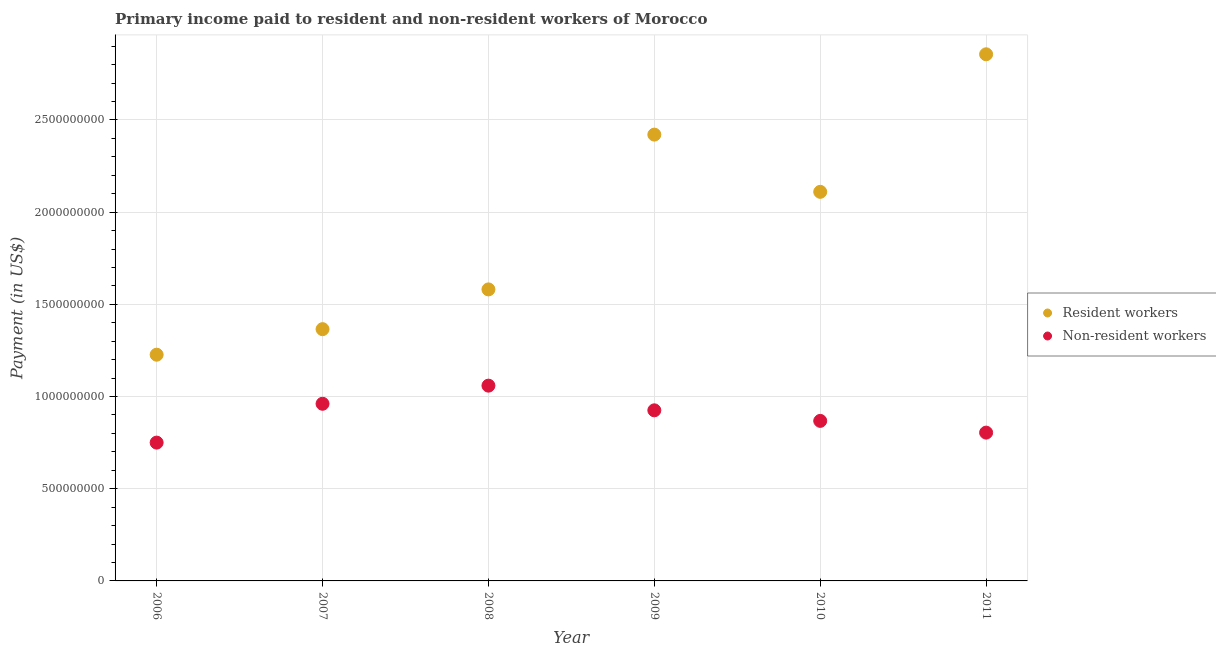What is the payment made to resident workers in 2010?
Your response must be concise. 2.11e+09. Across all years, what is the maximum payment made to resident workers?
Offer a very short reply. 2.86e+09. Across all years, what is the minimum payment made to resident workers?
Provide a succinct answer. 1.23e+09. In which year was the payment made to non-resident workers maximum?
Your response must be concise. 2008. What is the total payment made to resident workers in the graph?
Provide a succinct answer. 1.16e+1. What is the difference between the payment made to resident workers in 2007 and that in 2008?
Provide a succinct answer. -2.16e+08. What is the difference between the payment made to non-resident workers in 2010 and the payment made to resident workers in 2006?
Your response must be concise. -3.59e+08. What is the average payment made to resident workers per year?
Make the answer very short. 1.93e+09. In the year 2011, what is the difference between the payment made to non-resident workers and payment made to resident workers?
Provide a succinct answer. -2.05e+09. What is the ratio of the payment made to non-resident workers in 2010 to that in 2011?
Make the answer very short. 1.08. Is the payment made to non-resident workers in 2008 less than that in 2009?
Your answer should be very brief. No. Is the difference between the payment made to resident workers in 2007 and 2010 greater than the difference between the payment made to non-resident workers in 2007 and 2010?
Your answer should be compact. No. What is the difference between the highest and the second highest payment made to resident workers?
Your response must be concise. 4.36e+08. What is the difference between the highest and the lowest payment made to non-resident workers?
Make the answer very short. 3.09e+08. Is the sum of the payment made to resident workers in 2009 and 2011 greater than the maximum payment made to non-resident workers across all years?
Offer a terse response. Yes. Does the payment made to resident workers monotonically increase over the years?
Make the answer very short. No. Is the payment made to resident workers strictly greater than the payment made to non-resident workers over the years?
Ensure brevity in your answer.  Yes. How many years are there in the graph?
Provide a succinct answer. 6. What is the difference between two consecutive major ticks on the Y-axis?
Provide a succinct answer. 5.00e+08. Are the values on the major ticks of Y-axis written in scientific E-notation?
Your answer should be compact. No. Does the graph contain grids?
Your answer should be compact. Yes. Where does the legend appear in the graph?
Ensure brevity in your answer.  Center right. What is the title of the graph?
Your answer should be very brief. Primary income paid to resident and non-resident workers of Morocco. Does "Register a property" appear as one of the legend labels in the graph?
Your answer should be compact. No. What is the label or title of the Y-axis?
Make the answer very short. Payment (in US$). What is the Payment (in US$) in Resident workers in 2006?
Give a very brief answer. 1.23e+09. What is the Payment (in US$) of Non-resident workers in 2006?
Your response must be concise. 7.50e+08. What is the Payment (in US$) of Resident workers in 2007?
Make the answer very short. 1.37e+09. What is the Payment (in US$) in Non-resident workers in 2007?
Provide a short and direct response. 9.61e+08. What is the Payment (in US$) in Resident workers in 2008?
Offer a terse response. 1.58e+09. What is the Payment (in US$) in Non-resident workers in 2008?
Offer a very short reply. 1.06e+09. What is the Payment (in US$) in Resident workers in 2009?
Make the answer very short. 2.42e+09. What is the Payment (in US$) of Non-resident workers in 2009?
Make the answer very short. 9.25e+08. What is the Payment (in US$) in Resident workers in 2010?
Offer a terse response. 2.11e+09. What is the Payment (in US$) of Non-resident workers in 2010?
Give a very brief answer. 8.68e+08. What is the Payment (in US$) in Resident workers in 2011?
Your answer should be compact. 2.86e+09. What is the Payment (in US$) in Non-resident workers in 2011?
Give a very brief answer. 8.04e+08. Across all years, what is the maximum Payment (in US$) in Resident workers?
Provide a succinct answer. 2.86e+09. Across all years, what is the maximum Payment (in US$) of Non-resident workers?
Offer a terse response. 1.06e+09. Across all years, what is the minimum Payment (in US$) of Resident workers?
Your answer should be compact. 1.23e+09. Across all years, what is the minimum Payment (in US$) of Non-resident workers?
Keep it short and to the point. 7.50e+08. What is the total Payment (in US$) in Resident workers in the graph?
Offer a terse response. 1.16e+1. What is the total Payment (in US$) of Non-resident workers in the graph?
Ensure brevity in your answer.  5.37e+09. What is the difference between the Payment (in US$) of Resident workers in 2006 and that in 2007?
Your answer should be compact. -1.39e+08. What is the difference between the Payment (in US$) in Non-resident workers in 2006 and that in 2007?
Give a very brief answer. -2.11e+08. What is the difference between the Payment (in US$) of Resident workers in 2006 and that in 2008?
Your answer should be very brief. -3.54e+08. What is the difference between the Payment (in US$) of Non-resident workers in 2006 and that in 2008?
Provide a short and direct response. -3.09e+08. What is the difference between the Payment (in US$) in Resident workers in 2006 and that in 2009?
Your response must be concise. -1.19e+09. What is the difference between the Payment (in US$) of Non-resident workers in 2006 and that in 2009?
Keep it short and to the point. -1.75e+08. What is the difference between the Payment (in US$) of Resident workers in 2006 and that in 2010?
Keep it short and to the point. -8.83e+08. What is the difference between the Payment (in US$) of Non-resident workers in 2006 and that in 2010?
Your answer should be very brief. -1.18e+08. What is the difference between the Payment (in US$) in Resident workers in 2006 and that in 2011?
Keep it short and to the point. -1.63e+09. What is the difference between the Payment (in US$) in Non-resident workers in 2006 and that in 2011?
Your answer should be compact. -5.42e+07. What is the difference between the Payment (in US$) in Resident workers in 2007 and that in 2008?
Your answer should be compact. -2.16e+08. What is the difference between the Payment (in US$) of Non-resident workers in 2007 and that in 2008?
Your answer should be compact. -9.83e+07. What is the difference between the Payment (in US$) of Resident workers in 2007 and that in 2009?
Your answer should be compact. -1.06e+09. What is the difference between the Payment (in US$) of Non-resident workers in 2007 and that in 2009?
Your response must be concise. 3.55e+07. What is the difference between the Payment (in US$) of Resident workers in 2007 and that in 2010?
Provide a short and direct response. -7.45e+08. What is the difference between the Payment (in US$) of Non-resident workers in 2007 and that in 2010?
Ensure brevity in your answer.  9.28e+07. What is the difference between the Payment (in US$) in Resident workers in 2007 and that in 2011?
Make the answer very short. -1.49e+09. What is the difference between the Payment (in US$) in Non-resident workers in 2007 and that in 2011?
Your answer should be very brief. 1.56e+08. What is the difference between the Payment (in US$) of Resident workers in 2008 and that in 2009?
Make the answer very short. -8.40e+08. What is the difference between the Payment (in US$) in Non-resident workers in 2008 and that in 2009?
Give a very brief answer. 1.34e+08. What is the difference between the Payment (in US$) of Resident workers in 2008 and that in 2010?
Make the answer very short. -5.29e+08. What is the difference between the Payment (in US$) in Non-resident workers in 2008 and that in 2010?
Ensure brevity in your answer.  1.91e+08. What is the difference between the Payment (in US$) of Resident workers in 2008 and that in 2011?
Your response must be concise. -1.28e+09. What is the difference between the Payment (in US$) of Non-resident workers in 2008 and that in 2011?
Keep it short and to the point. 2.55e+08. What is the difference between the Payment (in US$) of Resident workers in 2009 and that in 2010?
Your answer should be very brief. 3.10e+08. What is the difference between the Payment (in US$) in Non-resident workers in 2009 and that in 2010?
Keep it short and to the point. 5.73e+07. What is the difference between the Payment (in US$) of Resident workers in 2009 and that in 2011?
Provide a short and direct response. -4.36e+08. What is the difference between the Payment (in US$) of Non-resident workers in 2009 and that in 2011?
Provide a short and direct response. 1.21e+08. What is the difference between the Payment (in US$) in Resident workers in 2010 and that in 2011?
Your response must be concise. -7.46e+08. What is the difference between the Payment (in US$) of Non-resident workers in 2010 and that in 2011?
Provide a short and direct response. 6.36e+07. What is the difference between the Payment (in US$) in Resident workers in 2006 and the Payment (in US$) in Non-resident workers in 2007?
Offer a very short reply. 2.66e+08. What is the difference between the Payment (in US$) of Resident workers in 2006 and the Payment (in US$) of Non-resident workers in 2008?
Your answer should be compact. 1.68e+08. What is the difference between the Payment (in US$) of Resident workers in 2006 and the Payment (in US$) of Non-resident workers in 2009?
Make the answer very short. 3.02e+08. What is the difference between the Payment (in US$) in Resident workers in 2006 and the Payment (in US$) in Non-resident workers in 2010?
Ensure brevity in your answer.  3.59e+08. What is the difference between the Payment (in US$) of Resident workers in 2006 and the Payment (in US$) of Non-resident workers in 2011?
Give a very brief answer. 4.23e+08. What is the difference between the Payment (in US$) of Resident workers in 2007 and the Payment (in US$) of Non-resident workers in 2008?
Give a very brief answer. 3.06e+08. What is the difference between the Payment (in US$) in Resident workers in 2007 and the Payment (in US$) in Non-resident workers in 2009?
Make the answer very short. 4.40e+08. What is the difference between the Payment (in US$) of Resident workers in 2007 and the Payment (in US$) of Non-resident workers in 2010?
Your answer should be very brief. 4.97e+08. What is the difference between the Payment (in US$) of Resident workers in 2007 and the Payment (in US$) of Non-resident workers in 2011?
Offer a terse response. 5.61e+08. What is the difference between the Payment (in US$) in Resident workers in 2008 and the Payment (in US$) in Non-resident workers in 2009?
Offer a terse response. 6.56e+08. What is the difference between the Payment (in US$) in Resident workers in 2008 and the Payment (in US$) in Non-resident workers in 2010?
Make the answer very short. 7.13e+08. What is the difference between the Payment (in US$) of Resident workers in 2008 and the Payment (in US$) of Non-resident workers in 2011?
Provide a short and direct response. 7.77e+08. What is the difference between the Payment (in US$) of Resident workers in 2009 and the Payment (in US$) of Non-resident workers in 2010?
Your answer should be compact. 1.55e+09. What is the difference between the Payment (in US$) in Resident workers in 2009 and the Payment (in US$) in Non-resident workers in 2011?
Your answer should be very brief. 1.62e+09. What is the difference between the Payment (in US$) of Resident workers in 2010 and the Payment (in US$) of Non-resident workers in 2011?
Offer a terse response. 1.31e+09. What is the average Payment (in US$) in Resident workers per year?
Provide a succinct answer. 1.93e+09. What is the average Payment (in US$) in Non-resident workers per year?
Provide a short and direct response. 8.95e+08. In the year 2006, what is the difference between the Payment (in US$) of Resident workers and Payment (in US$) of Non-resident workers?
Ensure brevity in your answer.  4.77e+08. In the year 2007, what is the difference between the Payment (in US$) of Resident workers and Payment (in US$) of Non-resident workers?
Offer a very short reply. 4.05e+08. In the year 2008, what is the difference between the Payment (in US$) of Resident workers and Payment (in US$) of Non-resident workers?
Ensure brevity in your answer.  5.22e+08. In the year 2009, what is the difference between the Payment (in US$) in Resident workers and Payment (in US$) in Non-resident workers?
Provide a succinct answer. 1.50e+09. In the year 2010, what is the difference between the Payment (in US$) of Resident workers and Payment (in US$) of Non-resident workers?
Ensure brevity in your answer.  1.24e+09. In the year 2011, what is the difference between the Payment (in US$) of Resident workers and Payment (in US$) of Non-resident workers?
Provide a short and direct response. 2.05e+09. What is the ratio of the Payment (in US$) in Resident workers in 2006 to that in 2007?
Your response must be concise. 0.9. What is the ratio of the Payment (in US$) of Non-resident workers in 2006 to that in 2007?
Offer a very short reply. 0.78. What is the ratio of the Payment (in US$) in Resident workers in 2006 to that in 2008?
Your answer should be compact. 0.78. What is the ratio of the Payment (in US$) of Non-resident workers in 2006 to that in 2008?
Offer a very short reply. 0.71. What is the ratio of the Payment (in US$) in Resident workers in 2006 to that in 2009?
Offer a terse response. 0.51. What is the ratio of the Payment (in US$) in Non-resident workers in 2006 to that in 2009?
Offer a terse response. 0.81. What is the ratio of the Payment (in US$) of Resident workers in 2006 to that in 2010?
Offer a terse response. 0.58. What is the ratio of the Payment (in US$) in Non-resident workers in 2006 to that in 2010?
Offer a very short reply. 0.86. What is the ratio of the Payment (in US$) in Resident workers in 2006 to that in 2011?
Provide a succinct answer. 0.43. What is the ratio of the Payment (in US$) in Non-resident workers in 2006 to that in 2011?
Offer a terse response. 0.93. What is the ratio of the Payment (in US$) of Resident workers in 2007 to that in 2008?
Provide a succinct answer. 0.86. What is the ratio of the Payment (in US$) of Non-resident workers in 2007 to that in 2008?
Your answer should be compact. 0.91. What is the ratio of the Payment (in US$) in Resident workers in 2007 to that in 2009?
Give a very brief answer. 0.56. What is the ratio of the Payment (in US$) in Non-resident workers in 2007 to that in 2009?
Your answer should be very brief. 1.04. What is the ratio of the Payment (in US$) in Resident workers in 2007 to that in 2010?
Offer a terse response. 0.65. What is the ratio of the Payment (in US$) of Non-resident workers in 2007 to that in 2010?
Your response must be concise. 1.11. What is the ratio of the Payment (in US$) of Resident workers in 2007 to that in 2011?
Make the answer very short. 0.48. What is the ratio of the Payment (in US$) in Non-resident workers in 2007 to that in 2011?
Offer a terse response. 1.19. What is the ratio of the Payment (in US$) of Resident workers in 2008 to that in 2009?
Keep it short and to the point. 0.65. What is the ratio of the Payment (in US$) in Non-resident workers in 2008 to that in 2009?
Keep it short and to the point. 1.14. What is the ratio of the Payment (in US$) of Resident workers in 2008 to that in 2010?
Ensure brevity in your answer.  0.75. What is the ratio of the Payment (in US$) in Non-resident workers in 2008 to that in 2010?
Provide a succinct answer. 1.22. What is the ratio of the Payment (in US$) of Resident workers in 2008 to that in 2011?
Provide a succinct answer. 0.55. What is the ratio of the Payment (in US$) in Non-resident workers in 2008 to that in 2011?
Give a very brief answer. 1.32. What is the ratio of the Payment (in US$) of Resident workers in 2009 to that in 2010?
Offer a very short reply. 1.15. What is the ratio of the Payment (in US$) of Non-resident workers in 2009 to that in 2010?
Your response must be concise. 1.07. What is the ratio of the Payment (in US$) of Resident workers in 2009 to that in 2011?
Give a very brief answer. 0.85. What is the ratio of the Payment (in US$) in Non-resident workers in 2009 to that in 2011?
Offer a very short reply. 1.15. What is the ratio of the Payment (in US$) of Resident workers in 2010 to that in 2011?
Your response must be concise. 0.74. What is the ratio of the Payment (in US$) of Non-resident workers in 2010 to that in 2011?
Your response must be concise. 1.08. What is the difference between the highest and the second highest Payment (in US$) in Resident workers?
Offer a very short reply. 4.36e+08. What is the difference between the highest and the second highest Payment (in US$) in Non-resident workers?
Ensure brevity in your answer.  9.83e+07. What is the difference between the highest and the lowest Payment (in US$) in Resident workers?
Keep it short and to the point. 1.63e+09. What is the difference between the highest and the lowest Payment (in US$) of Non-resident workers?
Your answer should be very brief. 3.09e+08. 